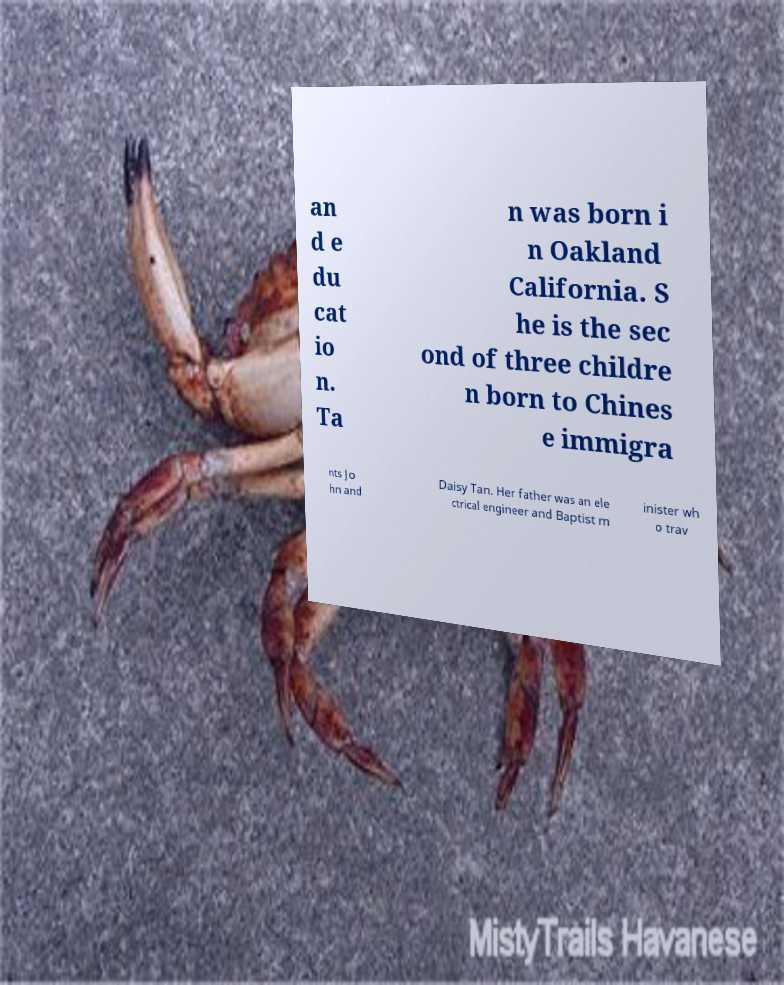Can you accurately transcribe the text from the provided image for me? an d e du cat io n. Ta n was born i n Oakland California. S he is the sec ond of three childre n born to Chines e immigra nts Jo hn and Daisy Tan. Her father was an ele ctrical engineer and Baptist m inister wh o trav 